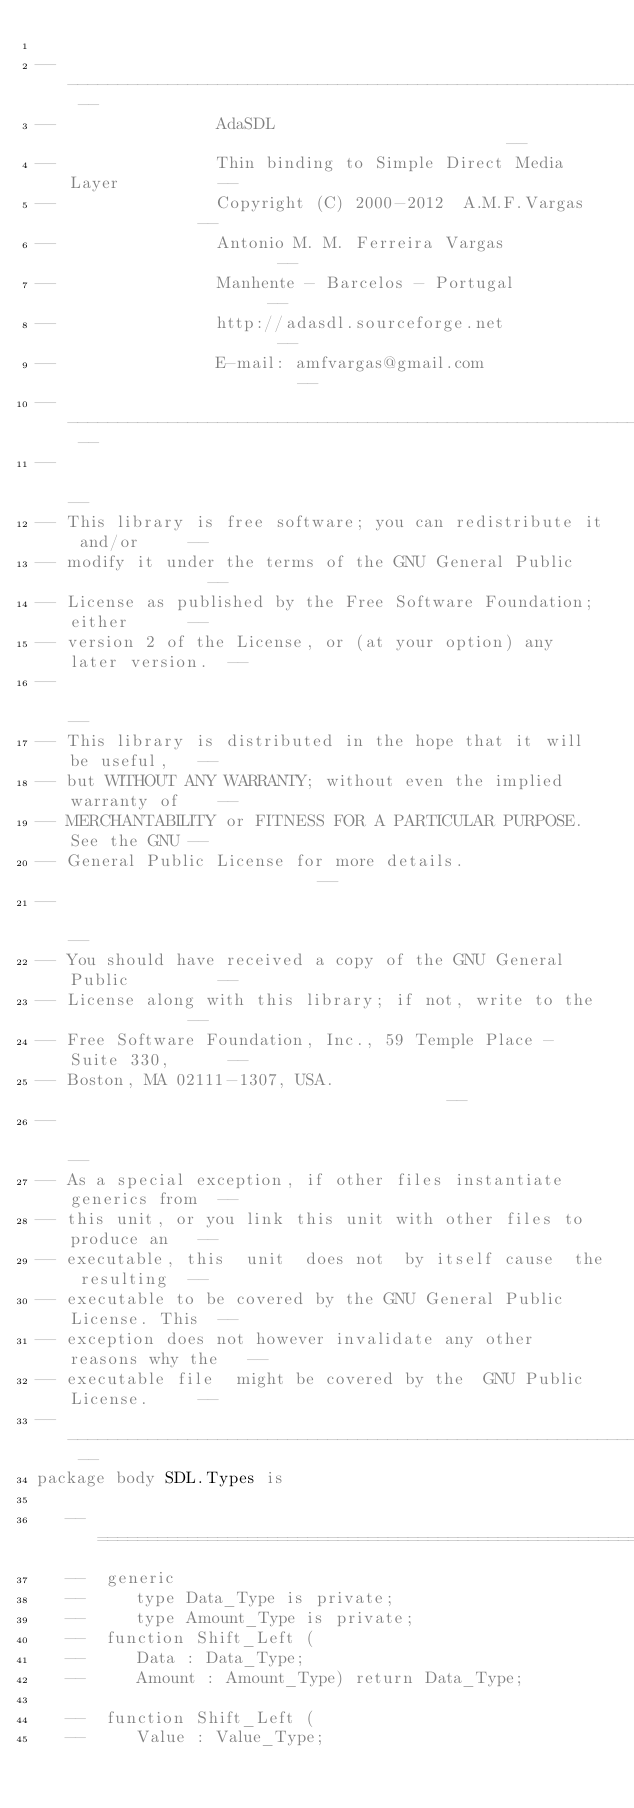<code> <loc_0><loc_0><loc_500><loc_500><_Ada_>
-- ----------------------------------------------------------------- --
--                AdaSDL                                             --
--                Thin binding to Simple Direct Media Layer          --
--                Copyright (C) 2000-2012  A.M.F.Vargas              --
--                Antonio M. M. Ferreira Vargas                      --
--                Manhente - Barcelos - Portugal                     --
--                http://adasdl.sourceforge.net                      --
--                E-mail: amfvargas@gmail.com                        --
-- ----------------------------------------------------------------- --
--                                                                   --
-- This library is free software; you can redistribute it and/or     --
-- modify it under the terms of the GNU General Public               --
-- License as published by the Free Software Foundation; either      --
-- version 2 of the License, or (at your option) any later version.  --
--                                                                   --
-- This library is distributed in the hope that it will be useful,   --
-- but WITHOUT ANY WARRANTY; without even the implied warranty of    --
-- MERCHANTABILITY or FITNESS FOR A PARTICULAR PURPOSE.  See the GNU --
-- General Public License for more details.                          --
--                                                                   --
-- You should have received a copy of the GNU General Public         --
-- License along with this library; if not, write to the             --
-- Free Software Foundation, Inc., 59 Temple Place - Suite 330,      --
-- Boston, MA 02111-1307, USA.                                       --
--                                                                   --
-- As a special exception, if other files instantiate generics from  --
-- this unit, or you link this unit with other files to produce an   --
-- executable, this  unit  does not  by itself cause  the resulting  --
-- executable to be covered by the GNU General Public License. This  --
-- exception does not however invalidate any other reasons why the   --
-- executable file  might be covered by the  GNU Public License.     --
-- ----------------------------------------------------------------- --
package body SDL.Types is

   --  ===================================================================
   --  generic
   --     type Data_Type is private;
   --     type Amount_Type is private;
   --  function Shift_Left (
   --     Data : Data_Type;
   --     Amount : Amount_Type) return Data_Type;

   --  function Shift_Left (
   --     Value : Value_Type;</code> 